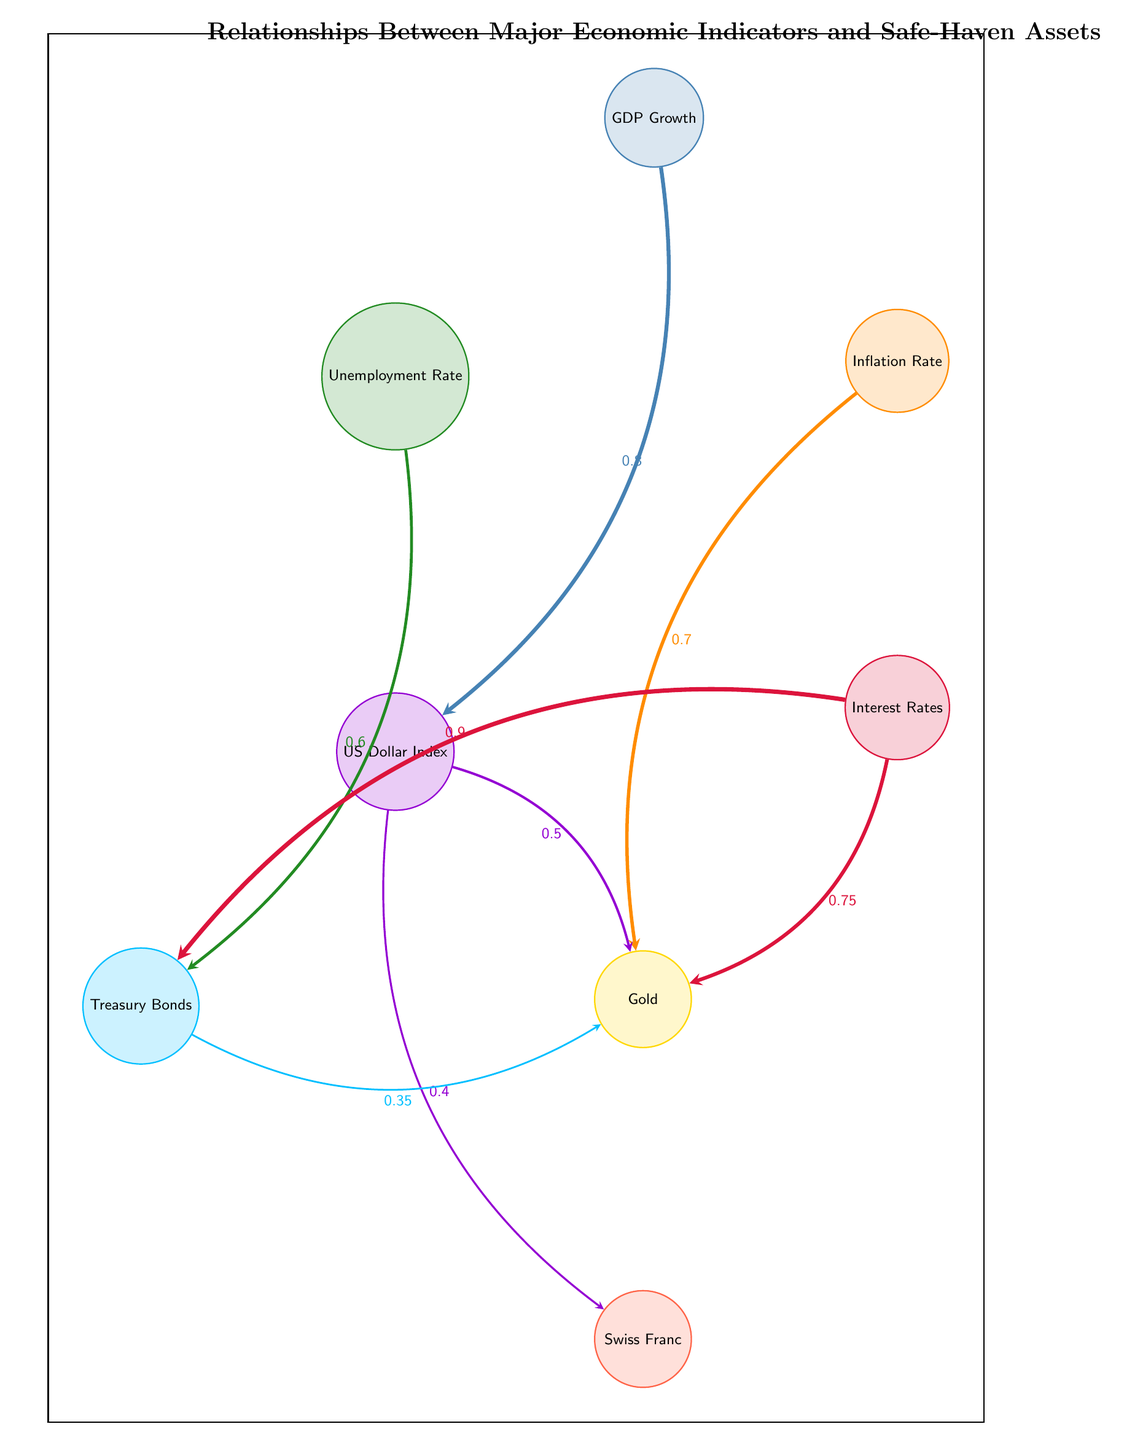What is the highest correlation value in the diagram? The highest correlation value in the diagram is between Interest Rates and Treasury Bonds, which is 0.9. This can be traced directly by reviewing the links surrounding Treasury Bonds and identifying the link originating from Interest Rates.
Answer: 0.9 Which economic indicator has a direct link to Gold? Gold is directly linked to Inflation Rate, Interest Rates, and US Dollar Index. Each of these links can be identified by tracing the arrows from these indicators to Gold in the diagram.
Answer: Inflation Rate, Interest Rates, US Dollar Index How many economic indicators are depicted in this diagram? The diagram includes four economic indicators: GDP Growth, Inflation Rate, Unemployment Rate, and Interest Rates. By counting the nodes designated as economic indicators, we find four.
Answer: 4 Which relationship has the weakest connection value? The weakest connection value is between Treasury Bonds and Gold, which has a correlation value of 0.35. This can be determined by evaluating all the connections and identifying the smallest numerical value presented.
Answer: 0.35 What is the correlation between Interest Rates and Gold? The correlation between Interest Rates and Gold is 0.75. This is directly observable on the connection from Interest Rates to Gold, where the correlation value is noted beside the arrow.
Answer: 0.75 Which safe-haven asset is influenced by the US Dollar Index? The US Dollar Index has direct links to Swiss Franc and Gold, indicating that they are influenced by the movements of the US Dollar Index. This can be seen by looking at the directed arrows stemming from the US Dollar Index to each asset.
Answer: Swiss Franc, Gold Which indicator has the lowest connection value to any safe-haven asset? The lowest connecting value to a safe-haven asset is from US Dollar Index to Swiss Franc, with a value of 0.4, which is the smallest number attached to any relationship involving safe-haven assets.
Answer: 0.4 How many safe-haven assets are linked to the economic indicators? There are three safe-haven assets linked to the economic indicators: Gold, Treasury Bonds, and Swiss Franc. By reviewing all the nodes designated as safe-haven assets, we can affirm their total presence in the diagram.
Answer: 3 What economic indicator is most closely related to Treasury Bonds? The economic indicator most closely related to Treasury Bonds is Interest Rates with the highest correlation value of 0.9. This is determined by identifying the strength of the connections between the economic indicators and Treasury Bonds.
Answer: Interest Rates 